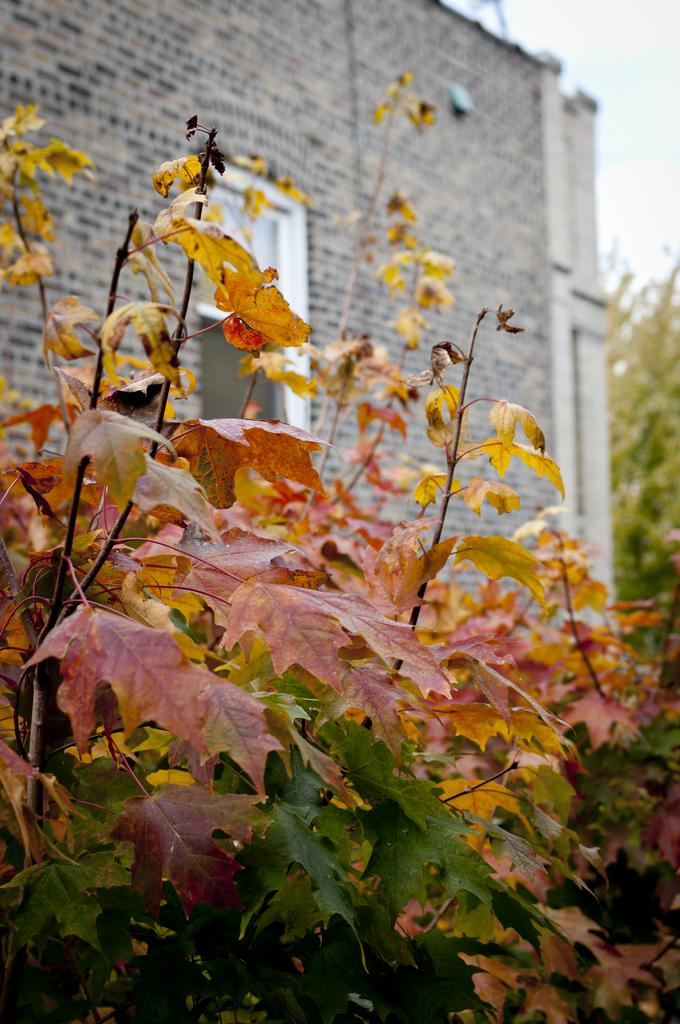What type of vegetation is in the front of the image? There are plants in the front of the image. What can be seen in the background of the image? There is a wall and a tree in the background of the image. What is the tendency of the person in the image to produce a specific result? There is no person present in the image, so it is not possible to determine any tendencies or results related to a person. 